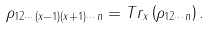<formula> <loc_0><loc_0><loc_500><loc_500>\rho _ { 1 2 \cdots ( x - 1 ) ( x + 1 ) \cdots n } = T r _ { x } \left ( \rho _ { 1 2 \cdots n } \right ) .</formula> 